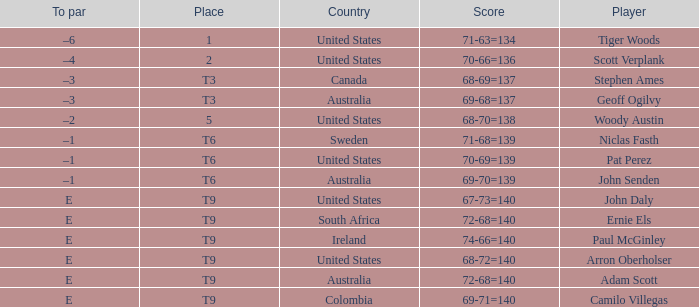What country is Adam Scott from? Australia. 